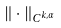<formula> <loc_0><loc_0><loc_500><loc_500>\| \cdot \| _ { C ^ { k , \alpha } }</formula> 